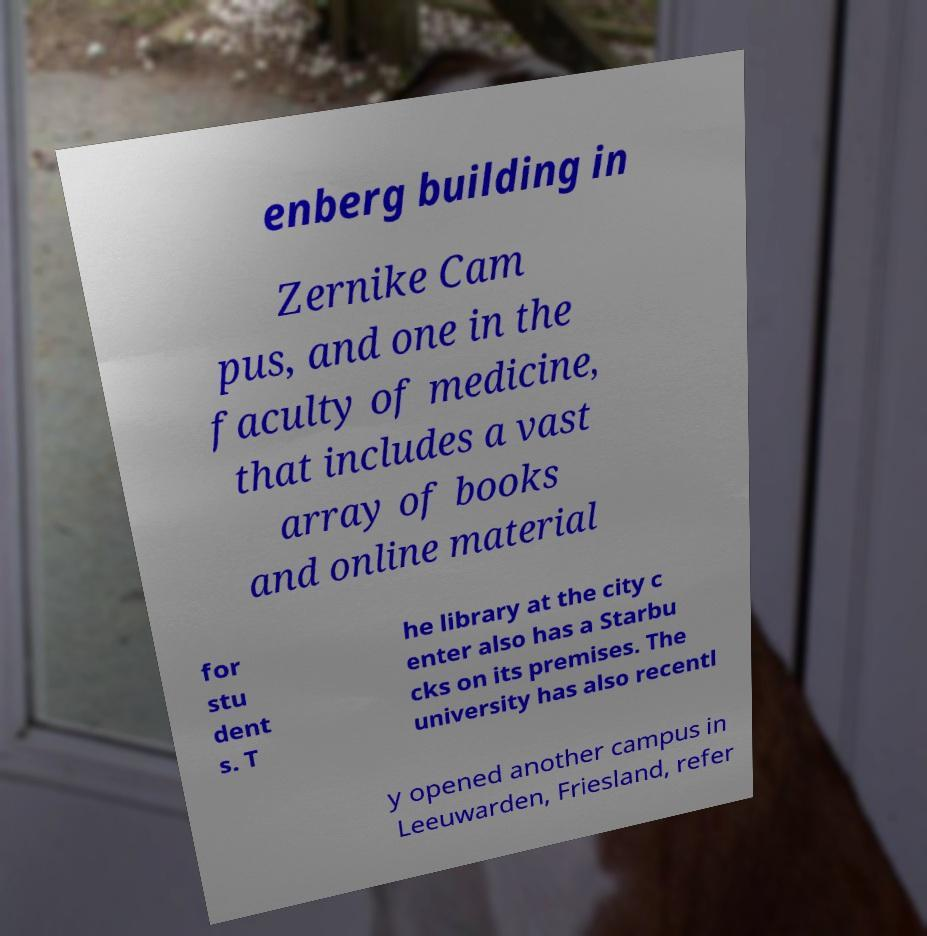Please read and relay the text visible in this image. What does it say? enberg building in Zernike Cam pus, and one in the faculty of medicine, that includes a vast array of books and online material for stu dent s. T he library at the city c enter also has a Starbu cks on its premises. The university has also recentl y opened another campus in Leeuwarden, Friesland, refer 